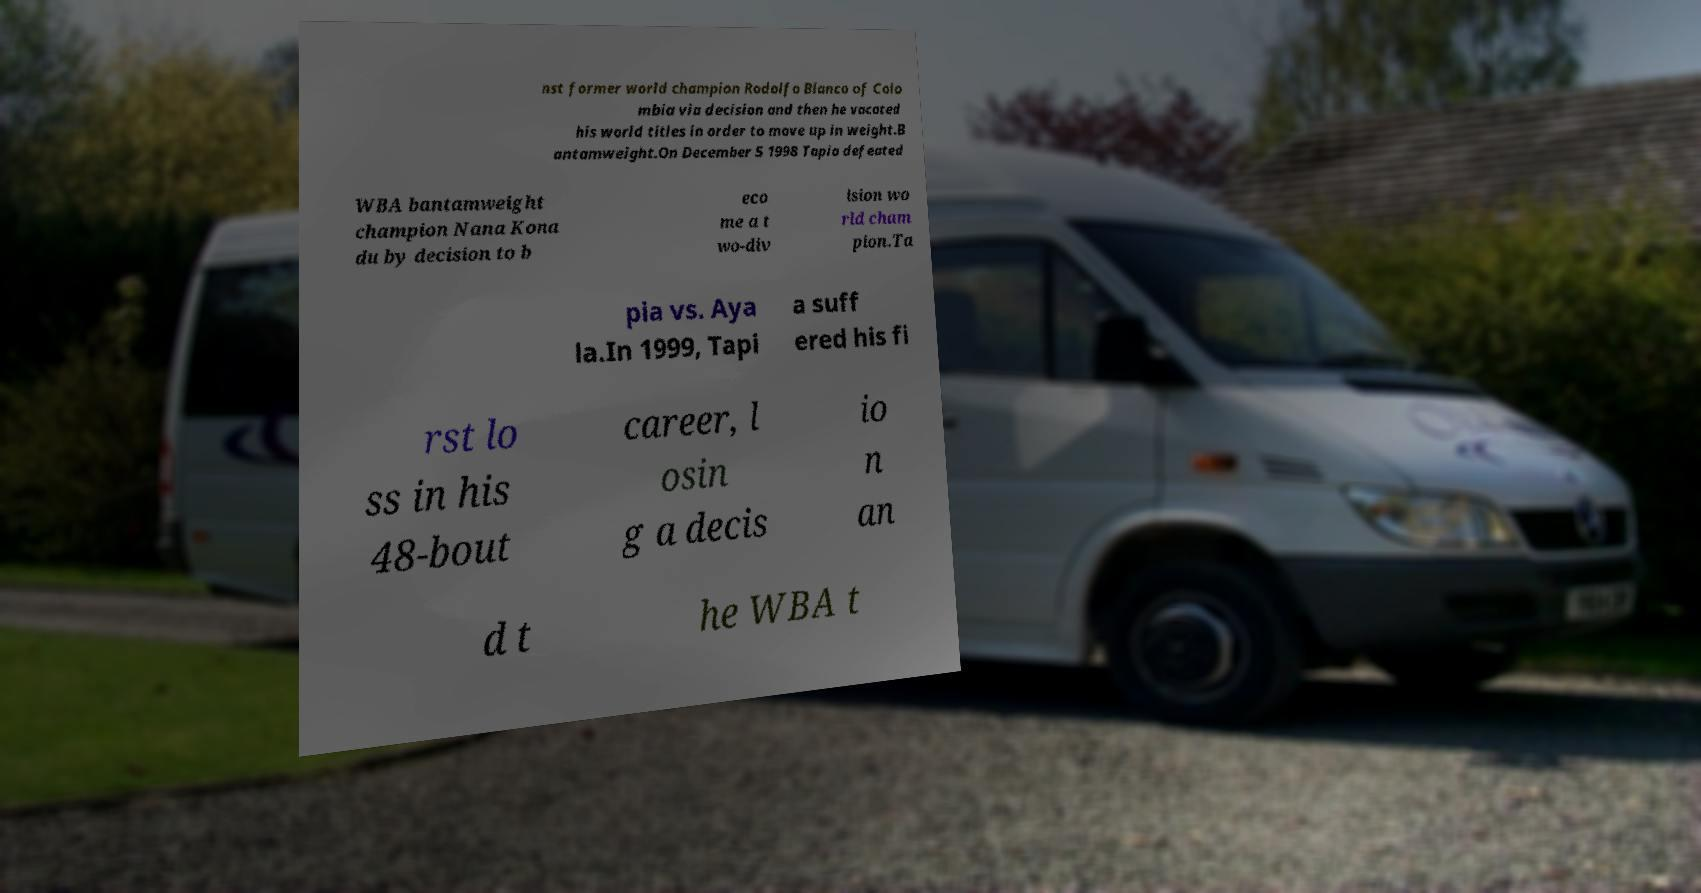Please read and relay the text visible in this image. What does it say? nst former world champion Rodolfo Blanco of Colo mbia via decision and then he vacated his world titles in order to move up in weight.B antamweight.On December 5 1998 Tapia defeated WBA bantamweight champion Nana Kona du by decision to b eco me a t wo-div ision wo rld cham pion.Ta pia vs. Aya la.In 1999, Tapi a suff ered his fi rst lo ss in his 48-bout career, l osin g a decis io n an d t he WBA t 